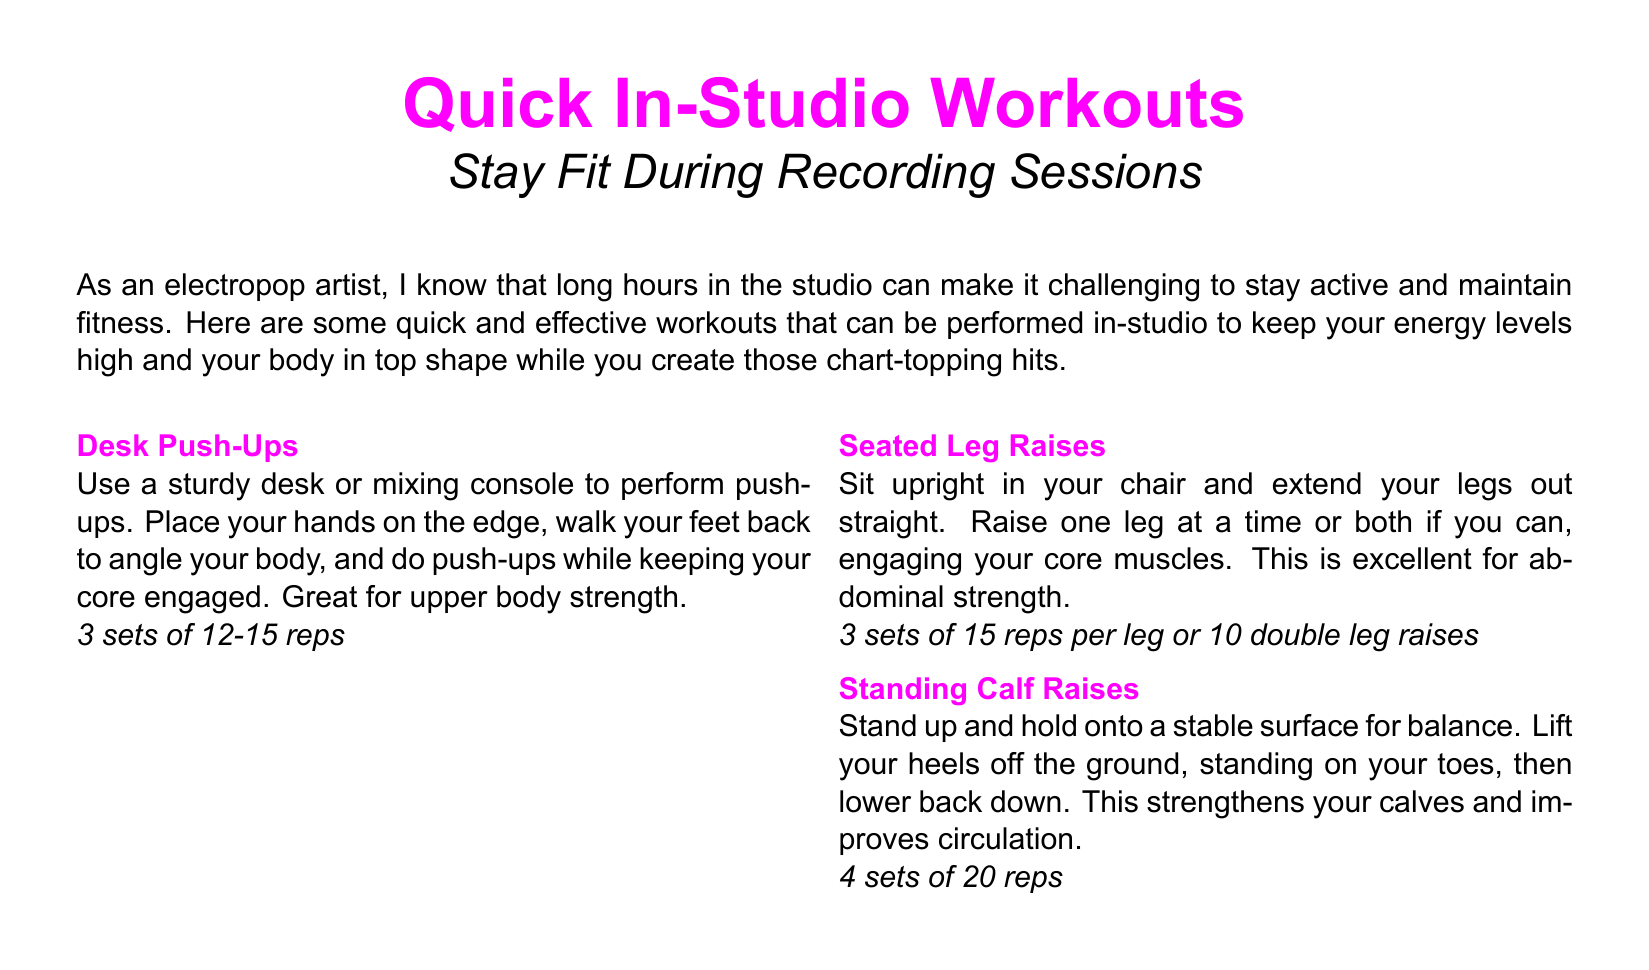What is the title of the document? The title is prominently displayed at the beginning of the document and provides an overview of the content, focusing on fitness during recording sessions.
Answer: Quick In-Studio Workouts How many sets are recommended for Desk Push-Ups? The document specifies the number of sets for each exercise, and for Desk Push-Ups, it is mentioned explicitly.
Answer: 3 sets What muscle group does Seated Leg Raises target? The document describes the Seated Leg Raises exercise's focus on core engagement, indicating the targeted muscle group.
Answer: Abdominal strength What is the recommended duration for holding each Neck Stretch? The document includes specific durations for various stretches, including Neck Stretches, detailing how long to hold each side.
Answer: 15-20 seconds How many reps are suggested for Standing Calf Raises? The document outlines the repetitions for Standing Calf Raises, providing a clear guideline for execution.
Answer: 20 reps What type of break is suggested in the workout plan? The document includes a fun activity interspersed among other exercises, encouraging a creative and carefree approach to workout breaks.
Answer: Mini Dance Break What does the closing note emphasize as a benefit of staying active? The closing note highlights the positive impact of fitness on artistic output and mental state, summarizing the reasons for incorporating workouts in sessions.
Answer: Energy and focus What should be the position of legs during Chair Dips? The document instructs on the proper form for Chair Dips, noting the positioning of the legs while performing the exercise.
Answer: Extended out 